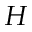<formula> <loc_0><loc_0><loc_500><loc_500>H</formula> 